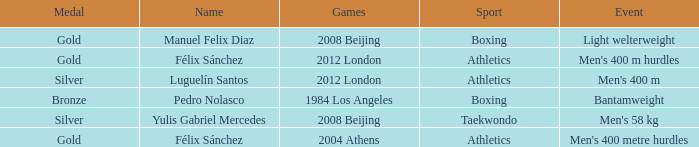Which Name had a Games of 2008 beijing, and a Medal of gold? Manuel Felix Diaz. 